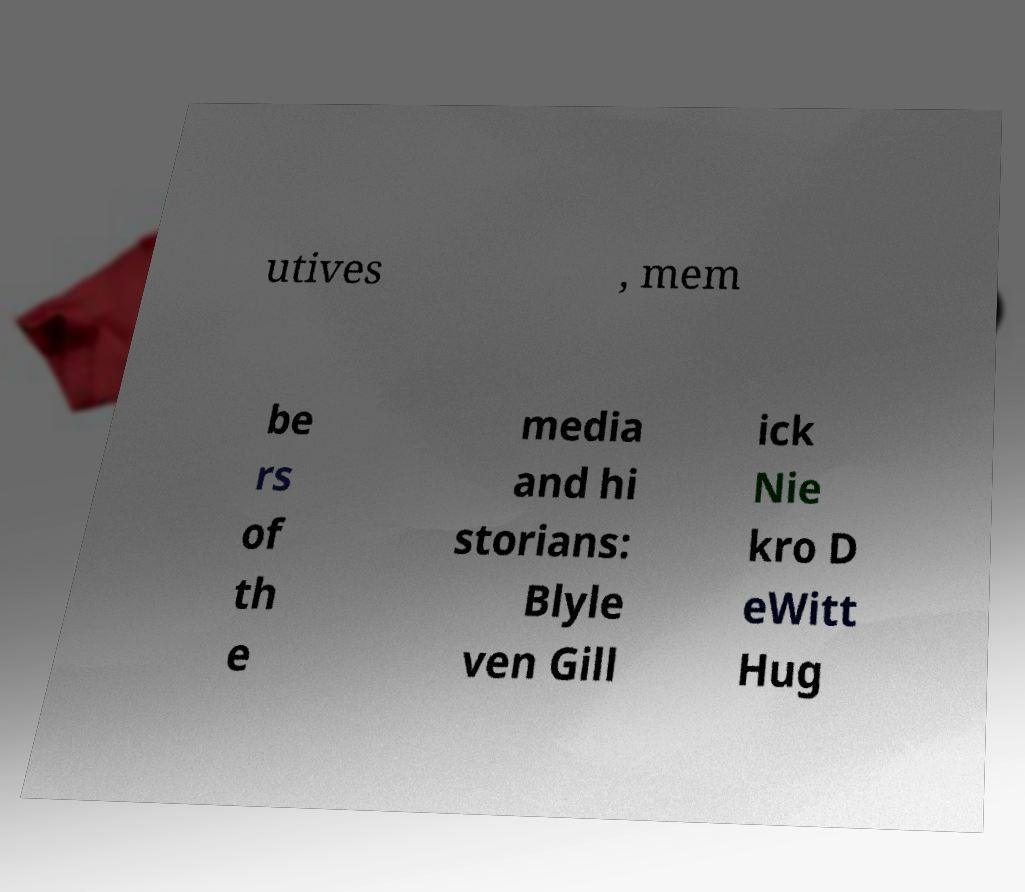Can you accurately transcribe the text from the provided image for me? utives , mem be rs of th e media and hi storians: Blyle ven Gill ick Nie kro D eWitt Hug 